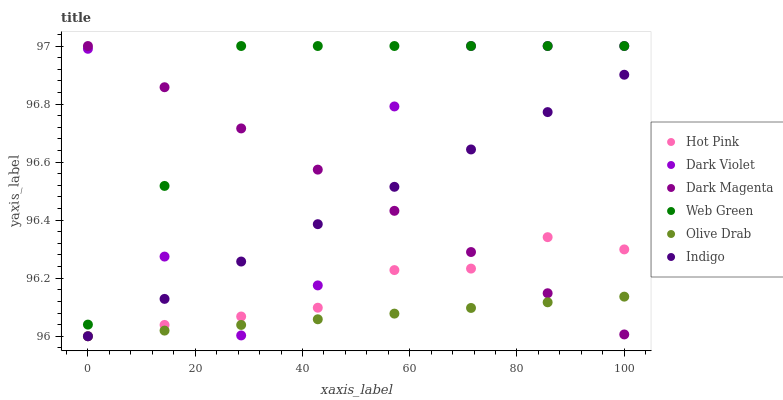Does Olive Drab have the minimum area under the curve?
Answer yes or no. Yes. Does Web Green have the maximum area under the curve?
Answer yes or no. Yes. Does Dark Magenta have the minimum area under the curve?
Answer yes or no. No. Does Dark Magenta have the maximum area under the curve?
Answer yes or no. No. Is Dark Magenta the smoothest?
Answer yes or no. Yes. Is Dark Violet the roughest?
Answer yes or no. Yes. Is Hot Pink the smoothest?
Answer yes or no. No. Is Hot Pink the roughest?
Answer yes or no. No. Does Indigo have the lowest value?
Answer yes or no. Yes. Does Dark Magenta have the lowest value?
Answer yes or no. No. Does Dark Violet have the highest value?
Answer yes or no. Yes. Does Hot Pink have the highest value?
Answer yes or no. No. Is Hot Pink less than Web Green?
Answer yes or no. Yes. Is Web Green greater than Olive Drab?
Answer yes or no. Yes. Does Dark Violet intersect Web Green?
Answer yes or no. Yes. Is Dark Violet less than Web Green?
Answer yes or no. No. Is Dark Violet greater than Web Green?
Answer yes or no. No. Does Hot Pink intersect Web Green?
Answer yes or no. No. 